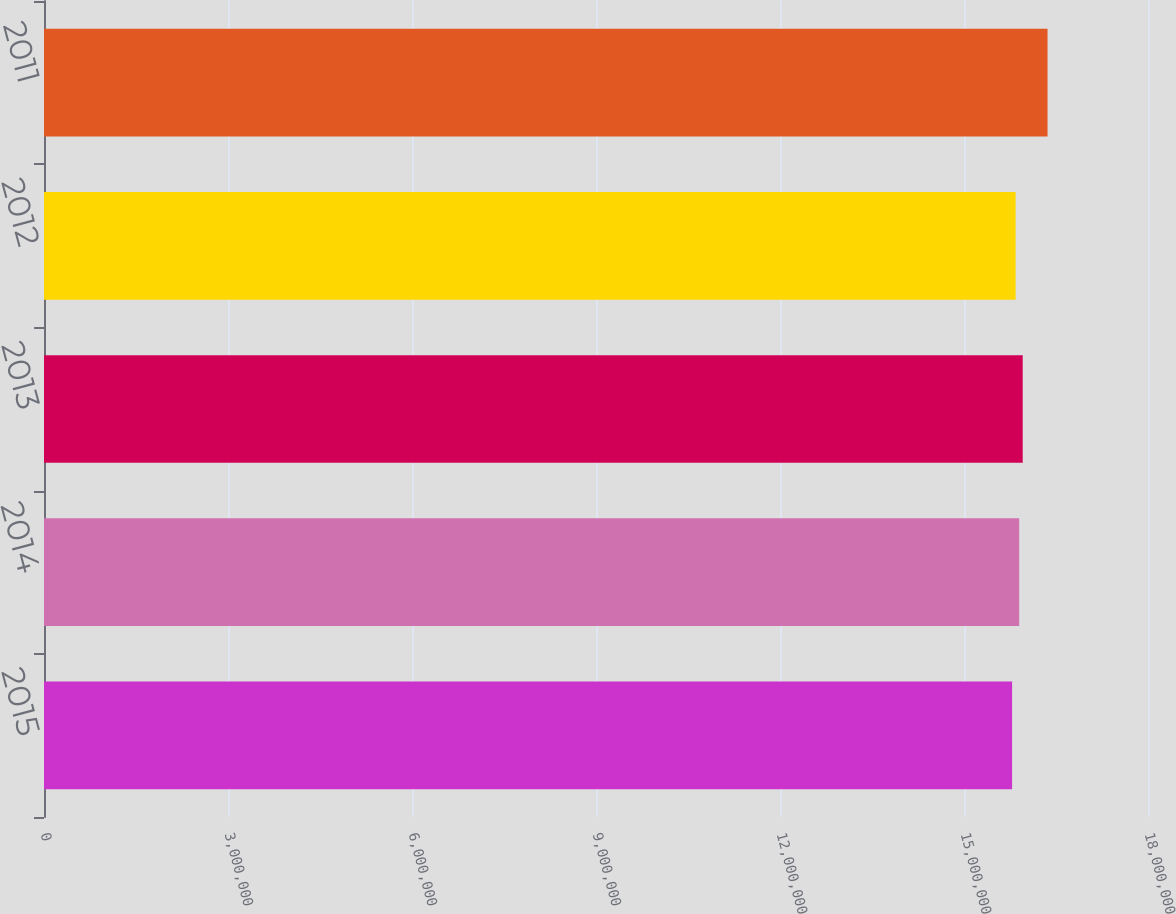Convert chart to OTSL. <chart><loc_0><loc_0><loc_500><loc_500><bar_chart><fcel>2015<fcel>2014<fcel>2013<fcel>2012<fcel>2011<nl><fcel>1.5784e+07<fcel>1.58996e+07<fcel>1.59574e+07<fcel>1.58418e+07<fcel>1.6362e+07<nl></chart> 